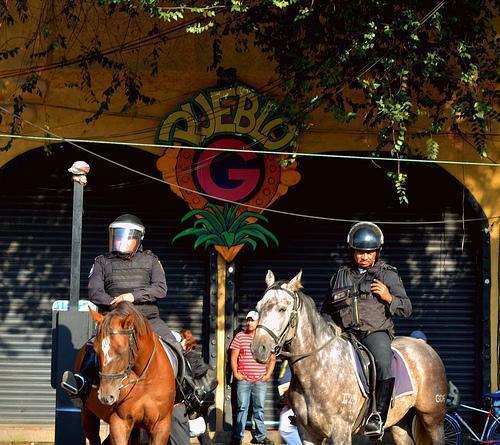How many caps are in the picture?
Give a very brief answer. 3. How many people are on horses?
Give a very brief answer. 2. How many horses are there?
Give a very brief answer. 2. How many bikes are in the photo?
Give a very brief answer. 1. How many horses are shown?
Give a very brief answer. 2. How many officers are shown?
Give a very brief answer. 2. 